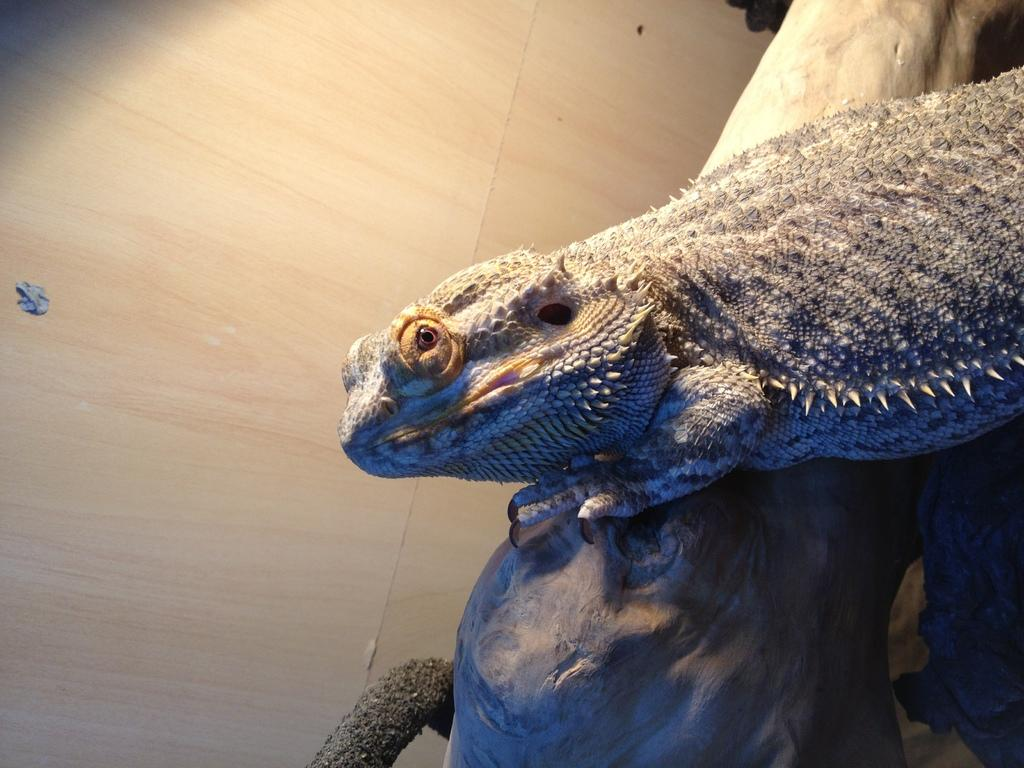What type of animal is in the image? There is a lizard in the image. Where is the lizard located? The lizard is on a log. What is the background of the image? The image shows a floor. What type of frogs can be seen swimming in the eggnog in the image? There are no frogs or eggnog present in the image; it features a lizard on a log with a floor as the background. 